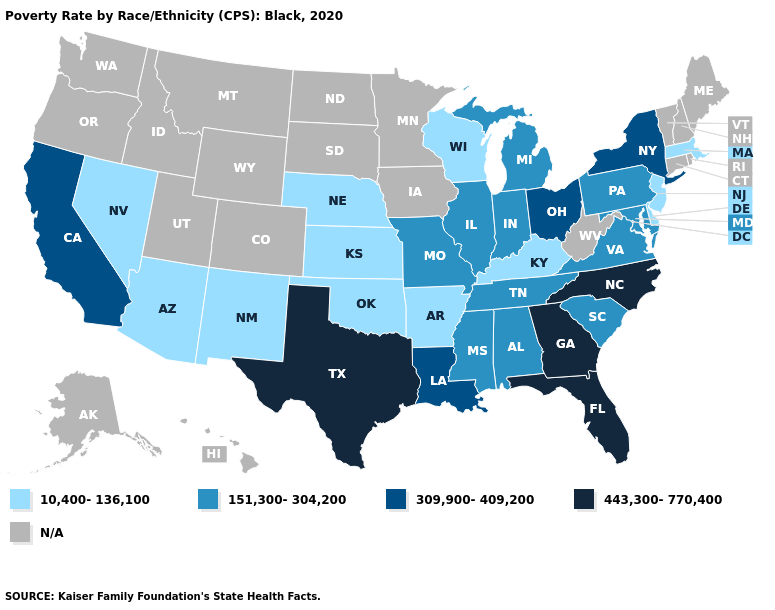Does Missouri have the lowest value in the USA?
Give a very brief answer. No. Is the legend a continuous bar?
Answer briefly. No. Does the first symbol in the legend represent the smallest category?
Write a very short answer. Yes. Name the states that have a value in the range 443,300-770,400?
Short answer required. Florida, Georgia, North Carolina, Texas. Name the states that have a value in the range 10,400-136,100?
Be succinct. Arizona, Arkansas, Delaware, Kansas, Kentucky, Massachusetts, Nebraska, Nevada, New Jersey, New Mexico, Oklahoma, Wisconsin. What is the lowest value in states that border Missouri?
Quick response, please. 10,400-136,100. What is the value of Utah?
Concise answer only. N/A. Name the states that have a value in the range 443,300-770,400?
Answer briefly. Florida, Georgia, North Carolina, Texas. What is the value of North Dakota?
Keep it brief. N/A. Does the map have missing data?
Write a very short answer. Yes. What is the highest value in states that border Ohio?
Answer briefly. 151,300-304,200. Name the states that have a value in the range 443,300-770,400?
Quick response, please. Florida, Georgia, North Carolina, Texas. Among the states that border Massachusetts , which have the lowest value?
Keep it brief. New York. What is the lowest value in the USA?
Short answer required. 10,400-136,100. Among the states that border Nevada , does Arizona have the lowest value?
Quick response, please. Yes. 